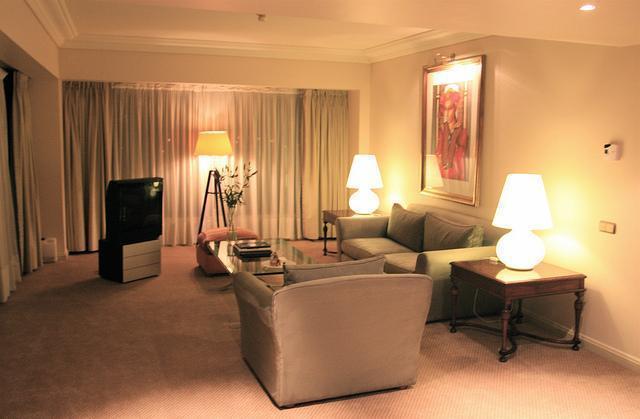What is the large black object used for?
Choose the correct response, then elucidate: 'Answer: answer
Rationale: rationale.'
Options: Watching television, eating, cooking, storage. Answer: watching television.
Rationale: You view shows and movies on this 